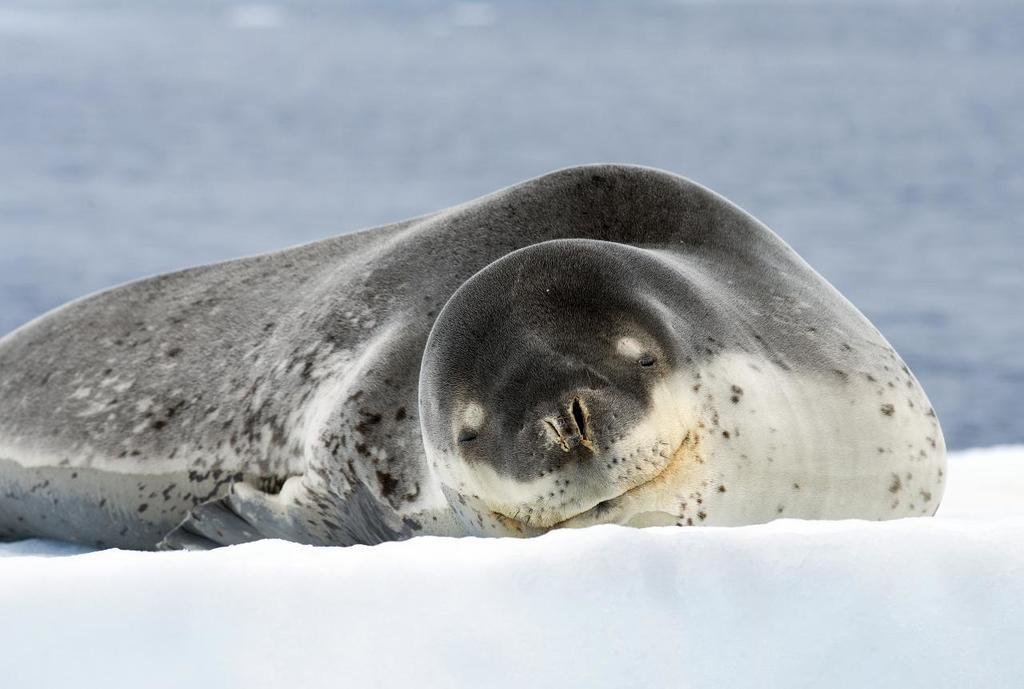What is the color of the seal in the image? The seal in the image is black. What is the color of the snow in the image? The snow in the image is white. What can be seen in the background of the image? Water is visible in the background of the image. What type of lettuce is being served for lunch in the image? There is no lettuce or lunch depicted in the image; it features a black seal and white snow with water in the background. 